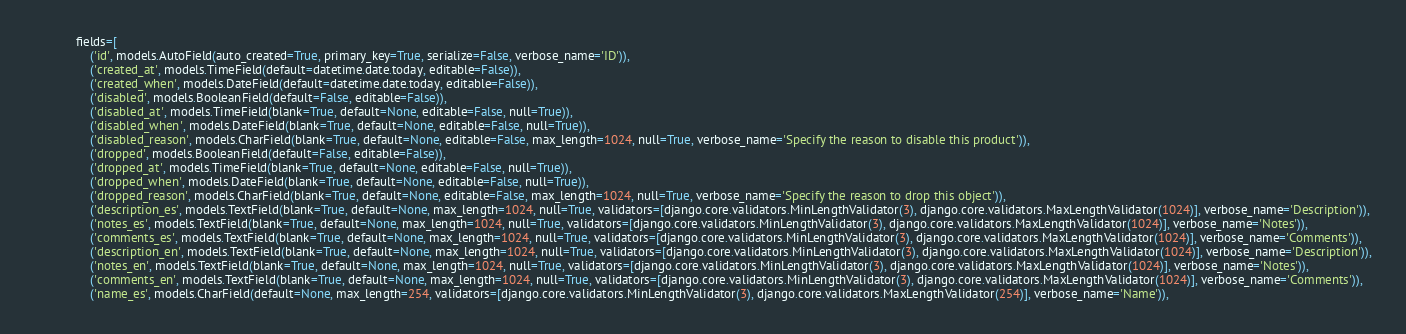<code> <loc_0><loc_0><loc_500><loc_500><_Python_>            fields=[
                ('id', models.AutoField(auto_created=True, primary_key=True, serialize=False, verbose_name='ID')),
                ('created_at', models.TimeField(default=datetime.date.today, editable=False)),
                ('created_when', models.DateField(default=datetime.date.today, editable=False)),
                ('disabled', models.BooleanField(default=False, editable=False)),
                ('disabled_at', models.TimeField(blank=True, default=None, editable=False, null=True)),
                ('disabled_when', models.DateField(blank=True, default=None, editable=False, null=True)),
                ('disabled_reason', models.CharField(blank=True, default=None, editable=False, max_length=1024, null=True, verbose_name='Specify the reason to disable this product')),
                ('dropped', models.BooleanField(default=False, editable=False)),
                ('dropped_at', models.TimeField(blank=True, default=None, editable=False, null=True)),
                ('dropped_when', models.DateField(blank=True, default=None, editable=False, null=True)),
                ('dropped_reason', models.CharField(blank=True, default=None, editable=False, max_length=1024, null=True, verbose_name='Specify the reason to drop this object')),
                ('description_es', models.TextField(blank=True, default=None, max_length=1024, null=True, validators=[django.core.validators.MinLengthValidator(3), django.core.validators.MaxLengthValidator(1024)], verbose_name='Description')),
                ('notes_es', models.TextField(blank=True, default=None, max_length=1024, null=True, validators=[django.core.validators.MinLengthValidator(3), django.core.validators.MaxLengthValidator(1024)], verbose_name='Notes')),
                ('comments_es', models.TextField(blank=True, default=None, max_length=1024, null=True, validators=[django.core.validators.MinLengthValidator(3), django.core.validators.MaxLengthValidator(1024)], verbose_name='Comments')),
                ('description_en', models.TextField(blank=True, default=None, max_length=1024, null=True, validators=[django.core.validators.MinLengthValidator(3), django.core.validators.MaxLengthValidator(1024)], verbose_name='Description')),
                ('notes_en', models.TextField(blank=True, default=None, max_length=1024, null=True, validators=[django.core.validators.MinLengthValidator(3), django.core.validators.MaxLengthValidator(1024)], verbose_name='Notes')),
                ('comments_en', models.TextField(blank=True, default=None, max_length=1024, null=True, validators=[django.core.validators.MinLengthValidator(3), django.core.validators.MaxLengthValidator(1024)], verbose_name='Comments')),
                ('name_es', models.CharField(default=None, max_length=254, validators=[django.core.validators.MinLengthValidator(3), django.core.validators.MaxLengthValidator(254)], verbose_name='Name')),</code> 